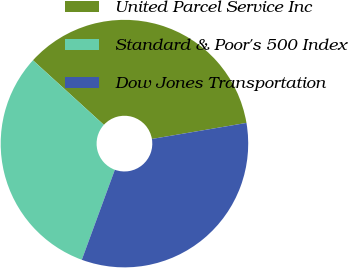Convert chart to OTSL. <chart><loc_0><loc_0><loc_500><loc_500><pie_chart><fcel>United Parcel Service Inc<fcel>Standard & Poor's 500 Index<fcel>Dow Jones Transportation<nl><fcel>35.57%<fcel>31.16%<fcel>33.27%<nl></chart> 